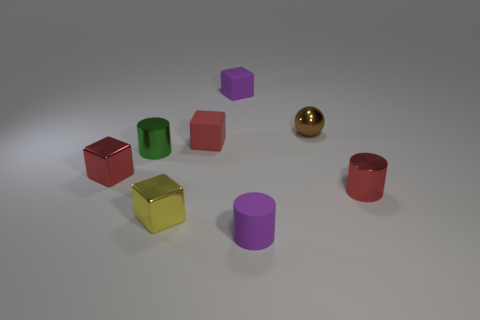Add 2 large brown matte cylinders. How many objects exist? 10 Subtract all cylinders. How many objects are left? 5 Subtract all red shiny cubes. Subtract all brown metallic spheres. How many objects are left? 6 Add 5 small brown metallic spheres. How many small brown metallic spheres are left? 6 Add 7 big red shiny cylinders. How many big red shiny cylinders exist? 7 Subtract 0 brown cylinders. How many objects are left? 8 